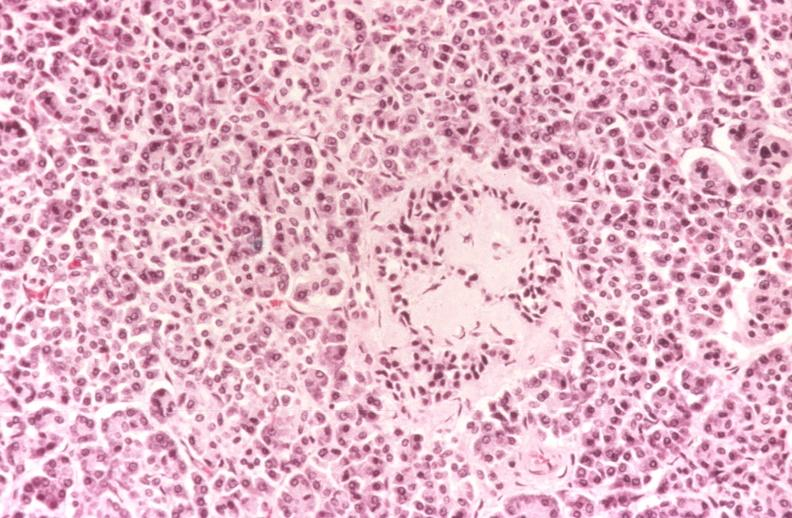does this image show kidney, glomerular amyloid, diabetes mellitus?
Answer the question using a single word or phrase. Yes 